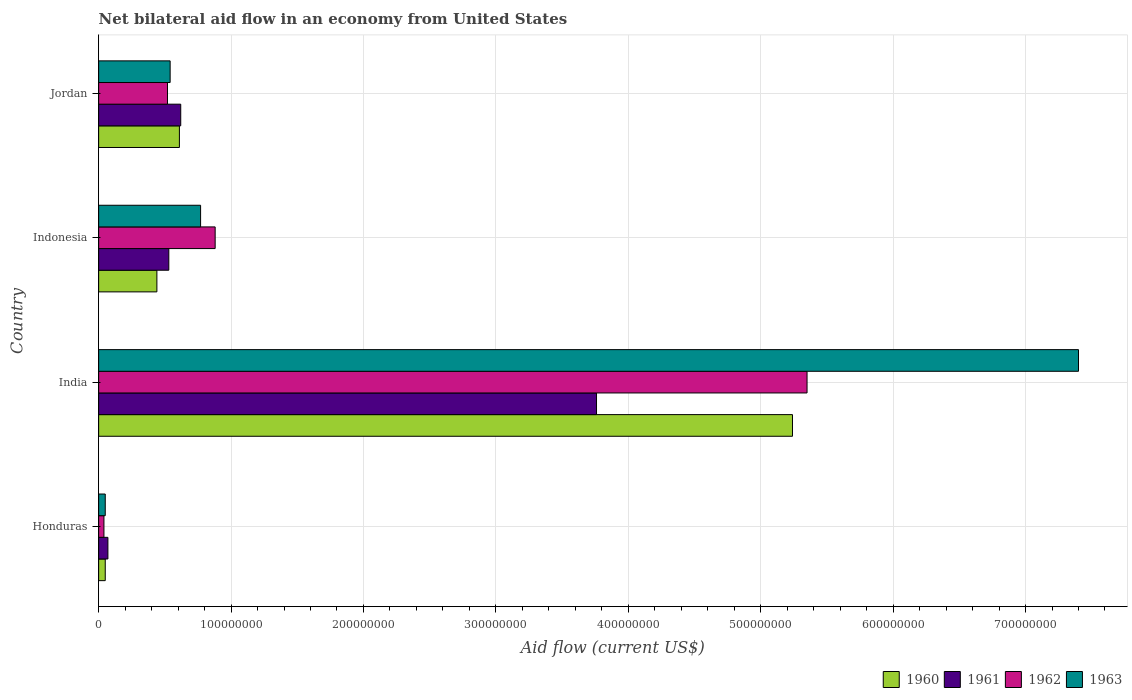How many different coloured bars are there?
Make the answer very short. 4. How many groups of bars are there?
Provide a short and direct response. 4. Are the number of bars per tick equal to the number of legend labels?
Provide a short and direct response. Yes. Are the number of bars on each tick of the Y-axis equal?
Make the answer very short. Yes. What is the label of the 3rd group of bars from the top?
Make the answer very short. India. In how many cases, is the number of bars for a given country not equal to the number of legend labels?
Offer a very short reply. 0. What is the net bilateral aid flow in 1961 in Jordan?
Make the answer very short. 6.20e+07. Across all countries, what is the maximum net bilateral aid flow in 1962?
Offer a terse response. 5.35e+08. In which country was the net bilateral aid flow in 1961 maximum?
Offer a terse response. India. In which country was the net bilateral aid flow in 1960 minimum?
Keep it short and to the point. Honduras. What is the total net bilateral aid flow in 1961 in the graph?
Provide a succinct answer. 4.98e+08. What is the difference between the net bilateral aid flow in 1963 in India and that in Indonesia?
Give a very brief answer. 6.63e+08. What is the difference between the net bilateral aid flow in 1960 in Jordan and the net bilateral aid flow in 1961 in Honduras?
Ensure brevity in your answer.  5.40e+07. What is the average net bilateral aid flow in 1962 per country?
Provide a succinct answer. 1.70e+08. In how many countries, is the net bilateral aid flow in 1963 greater than 620000000 US$?
Your answer should be compact. 1. What is the ratio of the net bilateral aid flow in 1961 in Honduras to that in Jordan?
Your answer should be very brief. 0.11. Is the difference between the net bilateral aid flow in 1961 in India and Jordan greater than the difference between the net bilateral aid flow in 1960 in India and Jordan?
Your response must be concise. No. What is the difference between the highest and the second highest net bilateral aid flow in 1961?
Offer a terse response. 3.14e+08. What is the difference between the highest and the lowest net bilateral aid flow in 1961?
Offer a terse response. 3.69e+08. In how many countries, is the net bilateral aid flow in 1960 greater than the average net bilateral aid flow in 1960 taken over all countries?
Provide a succinct answer. 1. What does the 4th bar from the bottom in India represents?
Ensure brevity in your answer.  1963. Is it the case that in every country, the sum of the net bilateral aid flow in 1962 and net bilateral aid flow in 1963 is greater than the net bilateral aid flow in 1960?
Provide a short and direct response. Yes. What is the difference between two consecutive major ticks on the X-axis?
Offer a terse response. 1.00e+08. Are the values on the major ticks of X-axis written in scientific E-notation?
Your answer should be very brief. No. Where does the legend appear in the graph?
Make the answer very short. Bottom right. What is the title of the graph?
Offer a terse response. Net bilateral aid flow in an economy from United States. Does "1994" appear as one of the legend labels in the graph?
Ensure brevity in your answer.  No. What is the Aid flow (current US$) of 1960 in Honduras?
Provide a succinct answer. 5.00e+06. What is the Aid flow (current US$) in 1961 in Honduras?
Give a very brief answer. 7.00e+06. What is the Aid flow (current US$) of 1962 in Honduras?
Provide a succinct answer. 4.00e+06. What is the Aid flow (current US$) of 1963 in Honduras?
Offer a very short reply. 5.00e+06. What is the Aid flow (current US$) of 1960 in India?
Your response must be concise. 5.24e+08. What is the Aid flow (current US$) in 1961 in India?
Ensure brevity in your answer.  3.76e+08. What is the Aid flow (current US$) of 1962 in India?
Offer a terse response. 5.35e+08. What is the Aid flow (current US$) in 1963 in India?
Provide a succinct answer. 7.40e+08. What is the Aid flow (current US$) of 1960 in Indonesia?
Offer a very short reply. 4.40e+07. What is the Aid flow (current US$) in 1961 in Indonesia?
Your response must be concise. 5.30e+07. What is the Aid flow (current US$) in 1962 in Indonesia?
Keep it short and to the point. 8.80e+07. What is the Aid flow (current US$) in 1963 in Indonesia?
Give a very brief answer. 7.70e+07. What is the Aid flow (current US$) in 1960 in Jordan?
Offer a terse response. 6.10e+07. What is the Aid flow (current US$) in 1961 in Jordan?
Your response must be concise. 6.20e+07. What is the Aid flow (current US$) in 1962 in Jordan?
Keep it short and to the point. 5.20e+07. What is the Aid flow (current US$) in 1963 in Jordan?
Your answer should be compact. 5.40e+07. Across all countries, what is the maximum Aid flow (current US$) of 1960?
Provide a succinct answer. 5.24e+08. Across all countries, what is the maximum Aid flow (current US$) in 1961?
Your answer should be compact. 3.76e+08. Across all countries, what is the maximum Aid flow (current US$) of 1962?
Provide a succinct answer. 5.35e+08. Across all countries, what is the maximum Aid flow (current US$) in 1963?
Ensure brevity in your answer.  7.40e+08. Across all countries, what is the minimum Aid flow (current US$) of 1960?
Keep it short and to the point. 5.00e+06. Across all countries, what is the minimum Aid flow (current US$) of 1961?
Your answer should be very brief. 7.00e+06. Across all countries, what is the minimum Aid flow (current US$) in 1963?
Your response must be concise. 5.00e+06. What is the total Aid flow (current US$) of 1960 in the graph?
Offer a very short reply. 6.34e+08. What is the total Aid flow (current US$) of 1961 in the graph?
Offer a very short reply. 4.98e+08. What is the total Aid flow (current US$) in 1962 in the graph?
Provide a short and direct response. 6.79e+08. What is the total Aid flow (current US$) in 1963 in the graph?
Your answer should be compact. 8.76e+08. What is the difference between the Aid flow (current US$) in 1960 in Honduras and that in India?
Your response must be concise. -5.19e+08. What is the difference between the Aid flow (current US$) of 1961 in Honduras and that in India?
Your response must be concise. -3.69e+08. What is the difference between the Aid flow (current US$) in 1962 in Honduras and that in India?
Provide a succinct answer. -5.31e+08. What is the difference between the Aid flow (current US$) in 1963 in Honduras and that in India?
Provide a short and direct response. -7.35e+08. What is the difference between the Aid flow (current US$) in 1960 in Honduras and that in Indonesia?
Keep it short and to the point. -3.90e+07. What is the difference between the Aid flow (current US$) of 1961 in Honduras and that in Indonesia?
Offer a terse response. -4.60e+07. What is the difference between the Aid flow (current US$) of 1962 in Honduras and that in Indonesia?
Give a very brief answer. -8.40e+07. What is the difference between the Aid flow (current US$) in 1963 in Honduras and that in Indonesia?
Your answer should be compact. -7.20e+07. What is the difference between the Aid flow (current US$) in 1960 in Honduras and that in Jordan?
Ensure brevity in your answer.  -5.60e+07. What is the difference between the Aid flow (current US$) in 1961 in Honduras and that in Jordan?
Your answer should be compact. -5.50e+07. What is the difference between the Aid flow (current US$) in 1962 in Honduras and that in Jordan?
Ensure brevity in your answer.  -4.80e+07. What is the difference between the Aid flow (current US$) of 1963 in Honduras and that in Jordan?
Your answer should be very brief. -4.90e+07. What is the difference between the Aid flow (current US$) of 1960 in India and that in Indonesia?
Your answer should be very brief. 4.80e+08. What is the difference between the Aid flow (current US$) of 1961 in India and that in Indonesia?
Provide a short and direct response. 3.23e+08. What is the difference between the Aid flow (current US$) of 1962 in India and that in Indonesia?
Your response must be concise. 4.47e+08. What is the difference between the Aid flow (current US$) of 1963 in India and that in Indonesia?
Provide a succinct answer. 6.63e+08. What is the difference between the Aid flow (current US$) of 1960 in India and that in Jordan?
Your answer should be very brief. 4.63e+08. What is the difference between the Aid flow (current US$) in 1961 in India and that in Jordan?
Your answer should be very brief. 3.14e+08. What is the difference between the Aid flow (current US$) of 1962 in India and that in Jordan?
Your answer should be compact. 4.83e+08. What is the difference between the Aid flow (current US$) in 1963 in India and that in Jordan?
Your answer should be compact. 6.86e+08. What is the difference between the Aid flow (current US$) in 1960 in Indonesia and that in Jordan?
Offer a very short reply. -1.70e+07. What is the difference between the Aid flow (current US$) of 1961 in Indonesia and that in Jordan?
Provide a succinct answer. -9.00e+06. What is the difference between the Aid flow (current US$) in 1962 in Indonesia and that in Jordan?
Your answer should be very brief. 3.60e+07. What is the difference between the Aid flow (current US$) in 1963 in Indonesia and that in Jordan?
Provide a short and direct response. 2.30e+07. What is the difference between the Aid flow (current US$) in 1960 in Honduras and the Aid flow (current US$) in 1961 in India?
Ensure brevity in your answer.  -3.71e+08. What is the difference between the Aid flow (current US$) in 1960 in Honduras and the Aid flow (current US$) in 1962 in India?
Your answer should be compact. -5.30e+08. What is the difference between the Aid flow (current US$) of 1960 in Honduras and the Aid flow (current US$) of 1963 in India?
Give a very brief answer. -7.35e+08. What is the difference between the Aid flow (current US$) of 1961 in Honduras and the Aid flow (current US$) of 1962 in India?
Your response must be concise. -5.28e+08. What is the difference between the Aid flow (current US$) of 1961 in Honduras and the Aid flow (current US$) of 1963 in India?
Your answer should be very brief. -7.33e+08. What is the difference between the Aid flow (current US$) in 1962 in Honduras and the Aid flow (current US$) in 1963 in India?
Offer a terse response. -7.36e+08. What is the difference between the Aid flow (current US$) in 1960 in Honduras and the Aid flow (current US$) in 1961 in Indonesia?
Provide a succinct answer. -4.80e+07. What is the difference between the Aid flow (current US$) of 1960 in Honduras and the Aid flow (current US$) of 1962 in Indonesia?
Provide a succinct answer. -8.30e+07. What is the difference between the Aid flow (current US$) in 1960 in Honduras and the Aid flow (current US$) in 1963 in Indonesia?
Ensure brevity in your answer.  -7.20e+07. What is the difference between the Aid flow (current US$) in 1961 in Honduras and the Aid flow (current US$) in 1962 in Indonesia?
Offer a terse response. -8.10e+07. What is the difference between the Aid flow (current US$) in 1961 in Honduras and the Aid flow (current US$) in 1963 in Indonesia?
Offer a terse response. -7.00e+07. What is the difference between the Aid flow (current US$) in 1962 in Honduras and the Aid flow (current US$) in 1963 in Indonesia?
Offer a terse response. -7.30e+07. What is the difference between the Aid flow (current US$) in 1960 in Honduras and the Aid flow (current US$) in 1961 in Jordan?
Provide a succinct answer. -5.70e+07. What is the difference between the Aid flow (current US$) in 1960 in Honduras and the Aid flow (current US$) in 1962 in Jordan?
Keep it short and to the point. -4.70e+07. What is the difference between the Aid flow (current US$) of 1960 in Honduras and the Aid flow (current US$) of 1963 in Jordan?
Give a very brief answer. -4.90e+07. What is the difference between the Aid flow (current US$) of 1961 in Honduras and the Aid flow (current US$) of 1962 in Jordan?
Offer a very short reply. -4.50e+07. What is the difference between the Aid flow (current US$) in 1961 in Honduras and the Aid flow (current US$) in 1963 in Jordan?
Your answer should be very brief. -4.70e+07. What is the difference between the Aid flow (current US$) of 1962 in Honduras and the Aid flow (current US$) of 1963 in Jordan?
Provide a succinct answer. -5.00e+07. What is the difference between the Aid flow (current US$) in 1960 in India and the Aid flow (current US$) in 1961 in Indonesia?
Offer a terse response. 4.71e+08. What is the difference between the Aid flow (current US$) in 1960 in India and the Aid flow (current US$) in 1962 in Indonesia?
Ensure brevity in your answer.  4.36e+08. What is the difference between the Aid flow (current US$) of 1960 in India and the Aid flow (current US$) of 1963 in Indonesia?
Provide a succinct answer. 4.47e+08. What is the difference between the Aid flow (current US$) in 1961 in India and the Aid flow (current US$) in 1962 in Indonesia?
Make the answer very short. 2.88e+08. What is the difference between the Aid flow (current US$) of 1961 in India and the Aid flow (current US$) of 1963 in Indonesia?
Your answer should be very brief. 2.99e+08. What is the difference between the Aid flow (current US$) in 1962 in India and the Aid flow (current US$) in 1963 in Indonesia?
Ensure brevity in your answer.  4.58e+08. What is the difference between the Aid flow (current US$) of 1960 in India and the Aid flow (current US$) of 1961 in Jordan?
Give a very brief answer. 4.62e+08. What is the difference between the Aid flow (current US$) of 1960 in India and the Aid flow (current US$) of 1962 in Jordan?
Offer a terse response. 4.72e+08. What is the difference between the Aid flow (current US$) in 1960 in India and the Aid flow (current US$) in 1963 in Jordan?
Your response must be concise. 4.70e+08. What is the difference between the Aid flow (current US$) in 1961 in India and the Aid flow (current US$) in 1962 in Jordan?
Provide a short and direct response. 3.24e+08. What is the difference between the Aid flow (current US$) in 1961 in India and the Aid flow (current US$) in 1963 in Jordan?
Keep it short and to the point. 3.22e+08. What is the difference between the Aid flow (current US$) of 1962 in India and the Aid flow (current US$) of 1963 in Jordan?
Provide a succinct answer. 4.81e+08. What is the difference between the Aid flow (current US$) in 1960 in Indonesia and the Aid flow (current US$) in 1961 in Jordan?
Your answer should be compact. -1.80e+07. What is the difference between the Aid flow (current US$) of 1960 in Indonesia and the Aid flow (current US$) of 1962 in Jordan?
Provide a succinct answer. -8.00e+06. What is the difference between the Aid flow (current US$) of 1960 in Indonesia and the Aid flow (current US$) of 1963 in Jordan?
Give a very brief answer. -1.00e+07. What is the difference between the Aid flow (current US$) of 1961 in Indonesia and the Aid flow (current US$) of 1962 in Jordan?
Your answer should be compact. 1.00e+06. What is the difference between the Aid flow (current US$) in 1961 in Indonesia and the Aid flow (current US$) in 1963 in Jordan?
Make the answer very short. -1.00e+06. What is the difference between the Aid flow (current US$) in 1962 in Indonesia and the Aid flow (current US$) in 1963 in Jordan?
Give a very brief answer. 3.40e+07. What is the average Aid flow (current US$) of 1960 per country?
Offer a terse response. 1.58e+08. What is the average Aid flow (current US$) of 1961 per country?
Your answer should be very brief. 1.24e+08. What is the average Aid flow (current US$) of 1962 per country?
Keep it short and to the point. 1.70e+08. What is the average Aid flow (current US$) of 1963 per country?
Your response must be concise. 2.19e+08. What is the difference between the Aid flow (current US$) of 1960 and Aid flow (current US$) of 1963 in Honduras?
Offer a terse response. 0. What is the difference between the Aid flow (current US$) of 1960 and Aid flow (current US$) of 1961 in India?
Make the answer very short. 1.48e+08. What is the difference between the Aid flow (current US$) of 1960 and Aid flow (current US$) of 1962 in India?
Keep it short and to the point. -1.10e+07. What is the difference between the Aid flow (current US$) of 1960 and Aid flow (current US$) of 1963 in India?
Keep it short and to the point. -2.16e+08. What is the difference between the Aid flow (current US$) of 1961 and Aid flow (current US$) of 1962 in India?
Provide a succinct answer. -1.59e+08. What is the difference between the Aid flow (current US$) in 1961 and Aid flow (current US$) in 1963 in India?
Keep it short and to the point. -3.64e+08. What is the difference between the Aid flow (current US$) in 1962 and Aid flow (current US$) in 1963 in India?
Your response must be concise. -2.05e+08. What is the difference between the Aid flow (current US$) of 1960 and Aid flow (current US$) of 1961 in Indonesia?
Your answer should be compact. -9.00e+06. What is the difference between the Aid flow (current US$) of 1960 and Aid flow (current US$) of 1962 in Indonesia?
Offer a terse response. -4.40e+07. What is the difference between the Aid flow (current US$) of 1960 and Aid flow (current US$) of 1963 in Indonesia?
Your answer should be compact. -3.30e+07. What is the difference between the Aid flow (current US$) in 1961 and Aid flow (current US$) in 1962 in Indonesia?
Your answer should be very brief. -3.50e+07. What is the difference between the Aid flow (current US$) in 1961 and Aid flow (current US$) in 1963 in Indonesia?
Your answer should be compact. -2.40e+07. What is the difference between the Aid flow (current US$) of 1962 and Aid flow (current US$) of 1963 in Indonesia?
Provide a short and direct response. 1.10e+07. What is the difference between the Aid flow (current US$) of 1960 and Aid flow (current US$) of 1962 in Jordan?
Offer a very short reply. 9.00e+06. What is the ratio of the Aid flow (current US$) of 1960 in Honduras to that in India?
Offer a terse response. 0.01. What is the ratio of the Aid flow (current US$) in 1961 in Honduras to that in India?
Keep it short and to the point. 0.02. What is the ratio of the Aid flow (current US$) in 1962 in Honduras to that in India?
Give a very brief answer. 0.01. What is the ratio of the Aid flow (current US$) of 1963 in Honduras to that in India?
Provide a succinct answer. 0.01. What is the ratio of the Aid flow (current US$) in 1960 in Honduras to that in Indonesia?
Offer a terse response. 0.11. What is the ratio of the Aid flow (current US$) of 1961 in Honduras to that in Indonesia?
Offer a very short reply. 0.13. What is the ratio of the Aid flow (current US$) of 1962 in Honduras to that in Indonesia?
Give a very brief answer. 0.05. What is the ratio of the Aid flow (current US$) of 1963 in Honduras to that in Indonesia?
Offer a very short reply. 0.06. What is the ratio of the Aid flow (current US$) in 1960 in Honduras to that in Jordan?
Make the answer very short. 0.08. What is the ratio of the Aid flow (current US$) in 1961 in Honduras to that in Jordan?
Your answer should be very brief. 0.11. What is the ratio of the Aid flow (current US$) of 1962 in Honduras to that in Jordan?
Your response must be concise. 0.08. What is the ratio of the Aid flow (current US$) in 1963 in Honduras to that in Jordan?
Your answer should be compact. 0.09. What is the ratio of the Aid flow (current US$) of 1960 in India to that in Indonesia?
Provide a succinct answer. 11.91. What is the ratio of the Aid flow (current US$) of 1961 in India to that in Indonesia?
Your answer should be very brief. 7.09. What is the ratio of the Aid flow (current US$) in 1962 in India to that in Indonesia?
Your response must be concise. 6.08. What is the ratio of the Aid flow (current US$) of 1963 in India to that in Indonesia?
Give a very brief answer. 9.61. What is the ratio of the Aid flow (current US$) in 1960 in India to that in Jordan?
Provide a succinct answer. 8.59. What is the ratio of the Aid flow (current US$) in 1961 in India to that in Jordan?
Your answer should be very brief. 6.06. What is the ratio of the Aid flow (current US$) in 1962 in India to that in Jordan?
Your answer should be very brief. 10.29. What is the ratio of the Aid flow (current US$) in 1963 in India to that in Jordan?
Your answer should be very brief. 13.7. What is the ratio of the Aid flow (current US$) in 1960 in Indonesia to that in Jordan?
Keep it short and to the point. 0.72. What is the ratio of the Aid flow (current US$) of 1961 in Indonesia to that in Jordan?
Your answer should be compact. 0.85. What is the ratio of the Aid flow (current US$) of 1962 in Indonesia to that in Jordan?
Make the answer very short. 1.69. What is the ratio of the Aid flow (current US$) in 1963 in Indonesia to that in Jordan?
Offer a terse response. 1.43. What is the difference between the highest and the second highest Aid flow (current US$) in 1960?
Your answer should be very brief. 4.63e+08. What is the difference between the highest and the second highest Aid flow (current US$) in 1961?
Your answer should be compact. 3.14e+08. What is the difference between the highest and the second highest Aid flow (current US$) in 1962?
Keep it short and to the point. 4.47e+08. What is the difference between the highest and the second highest Aid flow (current US$) of 1963?
Give a very brief answer. 6.63e+08. What is the difference between the highest and the lowest Aid flow (current US$) in 1960?
Your response must be concise. 5.19e+08. What is the difference between the highest and the lowest Aid flow (current US$) of 1961?
Give a very brief answer. 3.69e+08. What is the difference between the highest and the lowest Aid flow (current US$) in 1962?
Offer a terse response. 5.31e+08. What is the difference between the highest and the lowest Aid flow (current US$) in 1963?
Provide a succinct answer. 7.35e+08. 